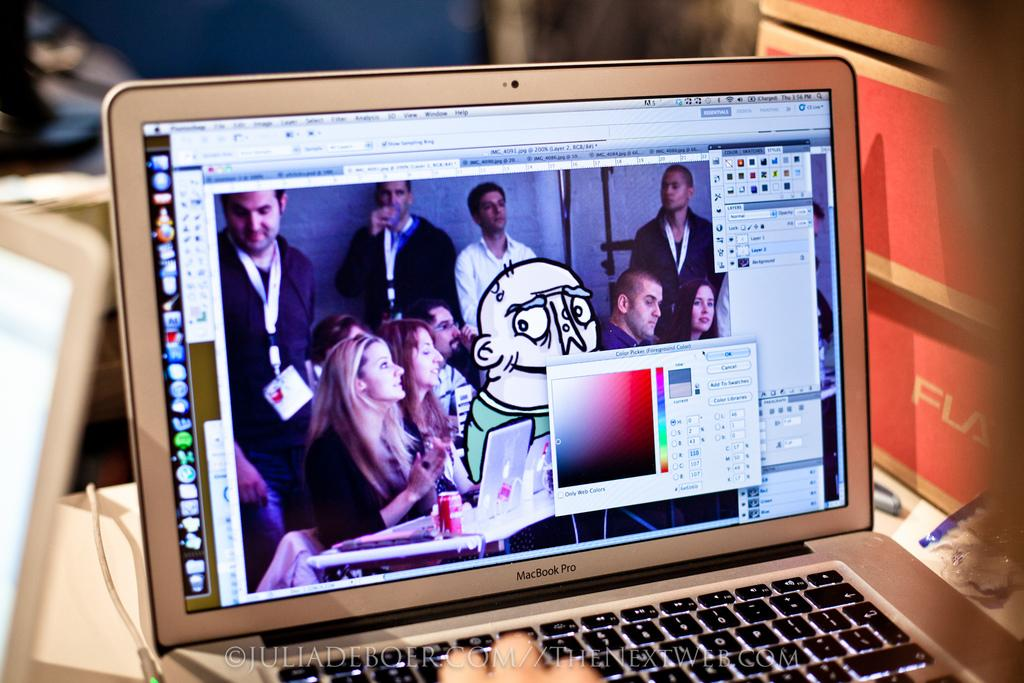<image>
Provide a brief description of the given image. a silver macbook pro laptop displying a photoshop session 